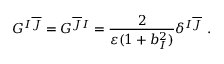<formula> <loc_0><loc_0><loc_500><loc_500>G ^ { I \overline { J } } = G ^ { \overline { J } I } = \frac { 2 } { \varepsilon ( 1 + b _ { I } ^ { 2 } ) } \delta ^ { I \overline { J } } .</formula> 